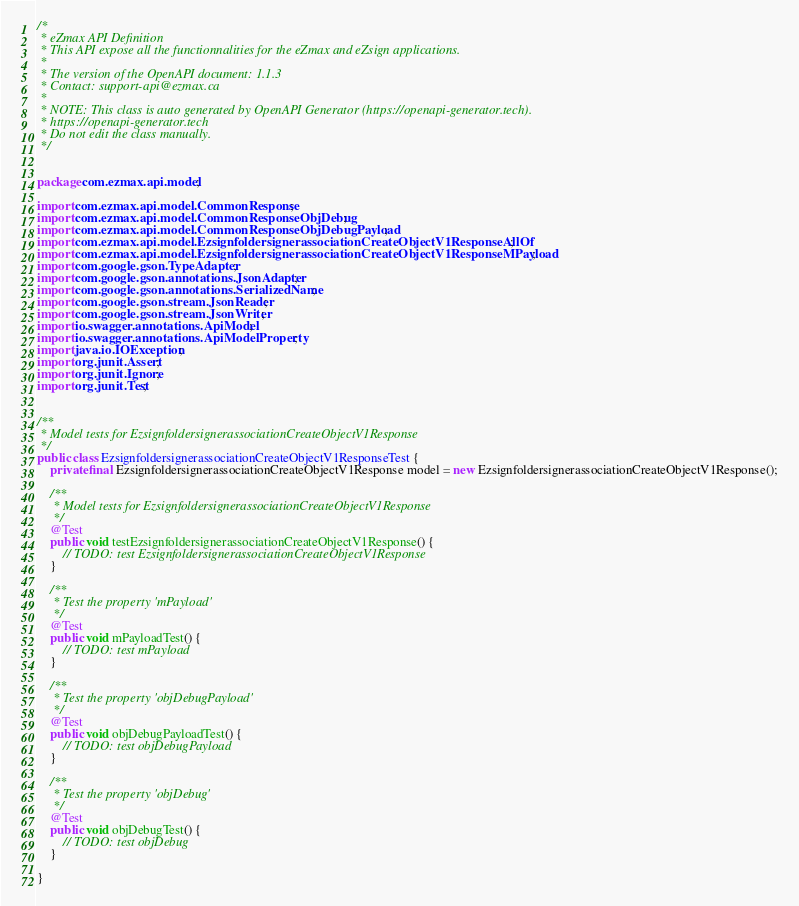Convert code to text. <code><loc_0><loc_0><loc_500><loc_500><_Java_>/*
 * eZmax API Definition
 * This API expose all the functionnalities for the eZmax and eZsign applications.
 *
 * The version of the OpenAPI document: 1.1.3
 * Contact: support-api@ezmax.ca
 *
 * NOTE: This class is auto generated by OpenAPI Generator (https://openapi-generator.tech).
 * https://openapi-generator.tech
 * Do not edit the class manually.
 */


package com.ezmax.api.model;

import com.ezmax.api.model.CommonResponse;
import com.ezmax.api.model.CommonResponseObjDebug;
import com.ezmax.api.model.CommonResponseObjDebugPayload;
import com.ezmax.api.model.EzsignfoldersignerassociationCreateObjectV1ResponseAllOf;
import com.ezmax.api.model.EzsignfoldersignerassociationCreateObjectV1ResponseMPayload;
import com.google.gson.TypeAdapter;
import com.google.gson.annotations.JsonAdapter;
import com.google.gson.annotations.SerializedName;
import com.google.gson.stream.JsonReader;
import com.google.gson.stream.JsonWriter;
import io.swagger.annotations.ApiModel;
import io.swagger.annotations.ApiModelProperty;
import java.io.IOException;
import org.junit.Assert;
import org.junit.Ignore;
import org.junit.Test;


/**
 * Model tests for EzsignfoldersignerassociationCreateObjectV1Response
 */
public class EzsignfoldersignerassociationCreateObjectV1ResponseTest {
    private final EzsignfoldersignerassociationCreateObjectV1Response model = new EzsignfoldersignerassociationCreateObjectV1Response();

    /**
     * Model tests for EzsignfoldersignerassociationCreateObjectV1Response
     */
    @Test
    public void testEzsignfoldersignerassociationCreateObjectV1Response() {
        // TODO: test EzsignfoldersignerassociationCreateObjectV1Response
    }

    /**
     * Test the property 'mPayload'
     */
    @Test
    public void mPayloadTest() {
        // TODO: test mPayload
    }

    /**
     * Test the property 'objDebugPayload'
     */
    @Test
    public void objDebugPayloadTest() {
        // TODO: test objDebugPayload
    }

    /**
     * Test the property 'objDebug'
     */
    @Test
    public void objDebugTest() {
        // TODO: test objDebug
    }

}
</code> 